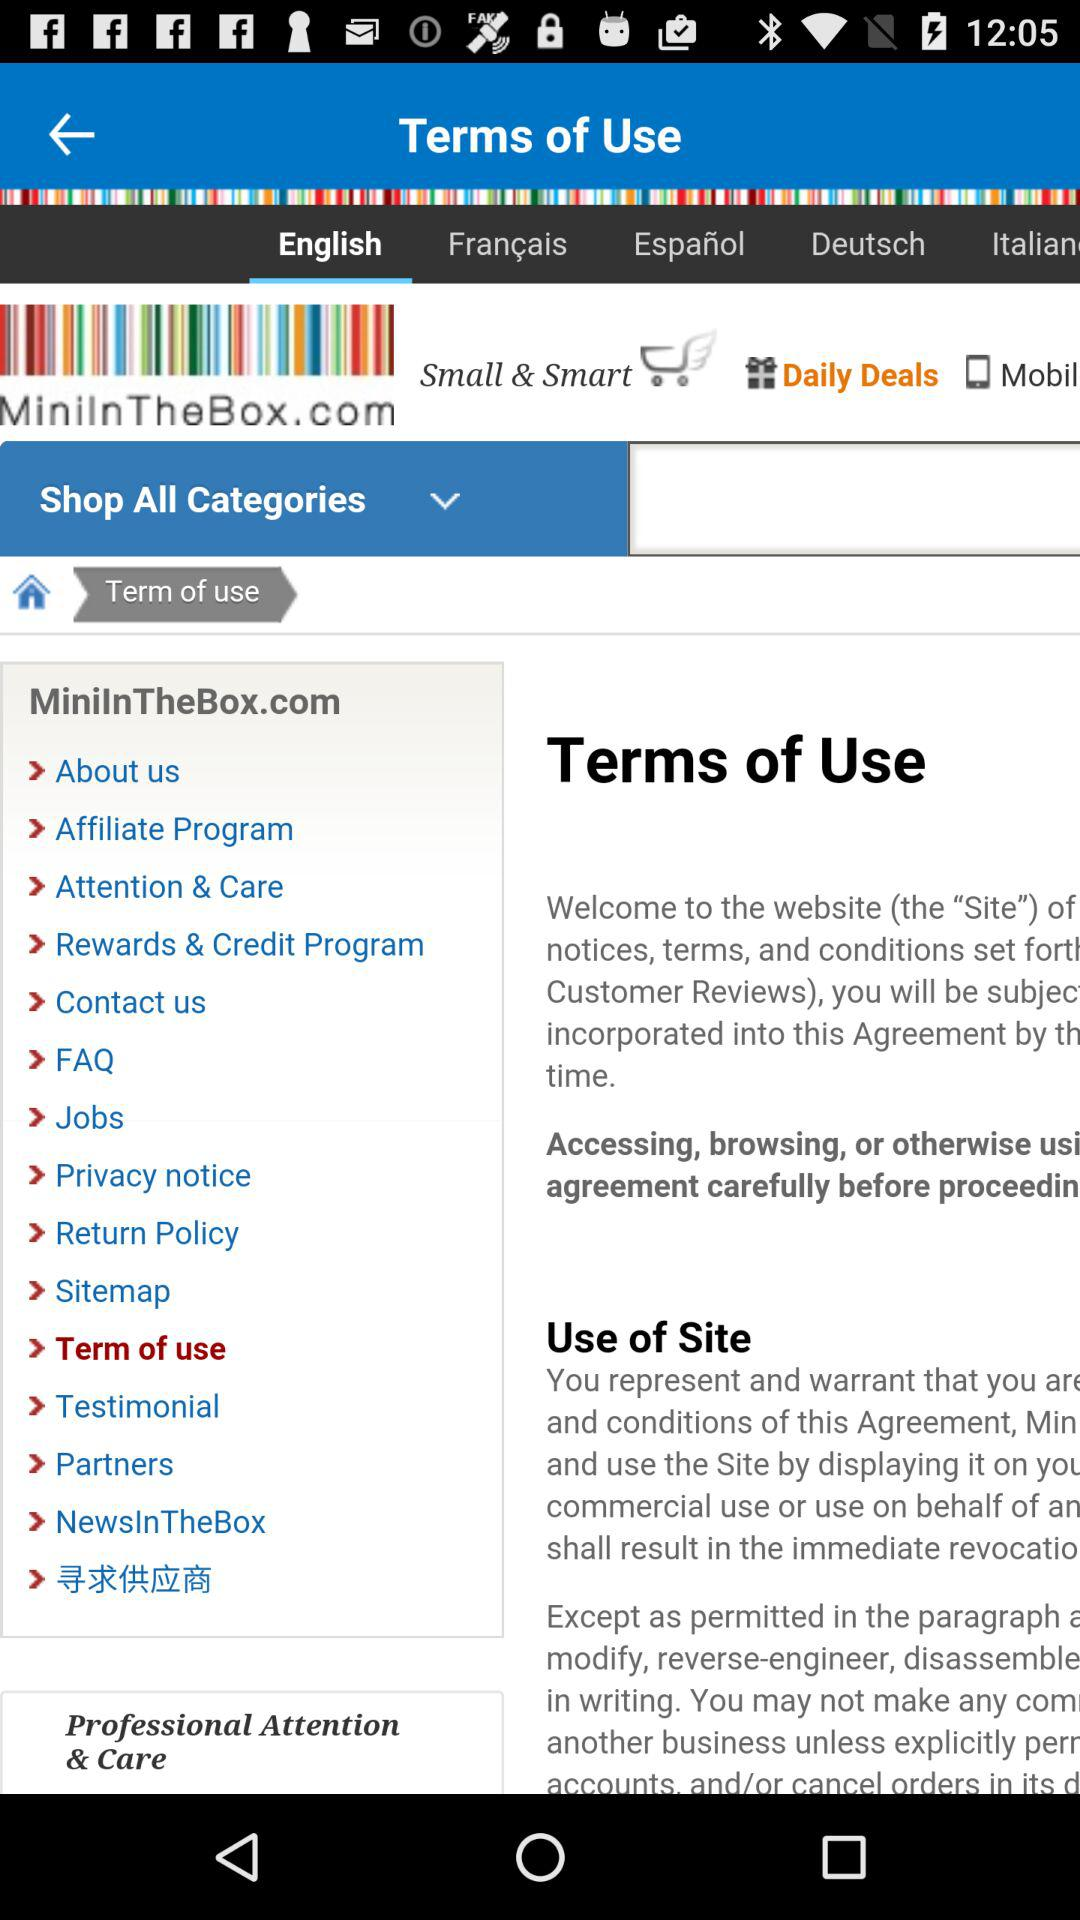Which language is selected? The selected language is "English". 